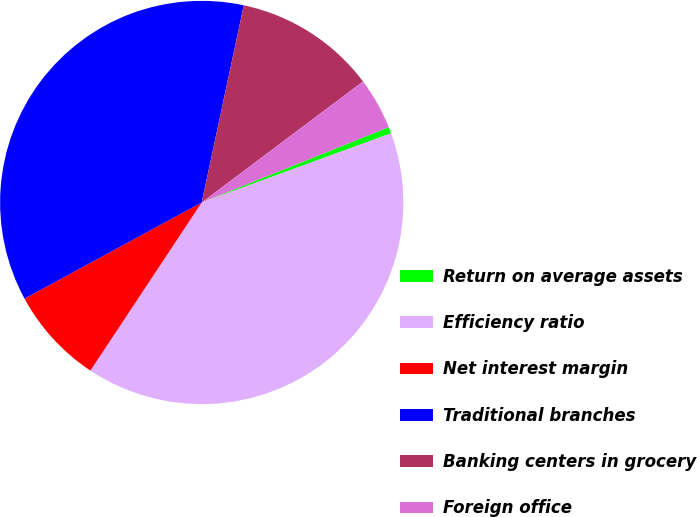<chart> <loc_0><loc_0><loc_500><loc_500><pie_chart><fcel>Return on average assets<fcel>Efficiency ratio<fcel>Net interest margin<fcel>Traditional branches<fcel>Banking centers in grocery<fcel>Foreign office<nl><fcel>0.52%<fcel>39.88%<fcel>7.78%<fcel>36.25%<fcel>11.41%<fcel>4.15%<nl></chart> 